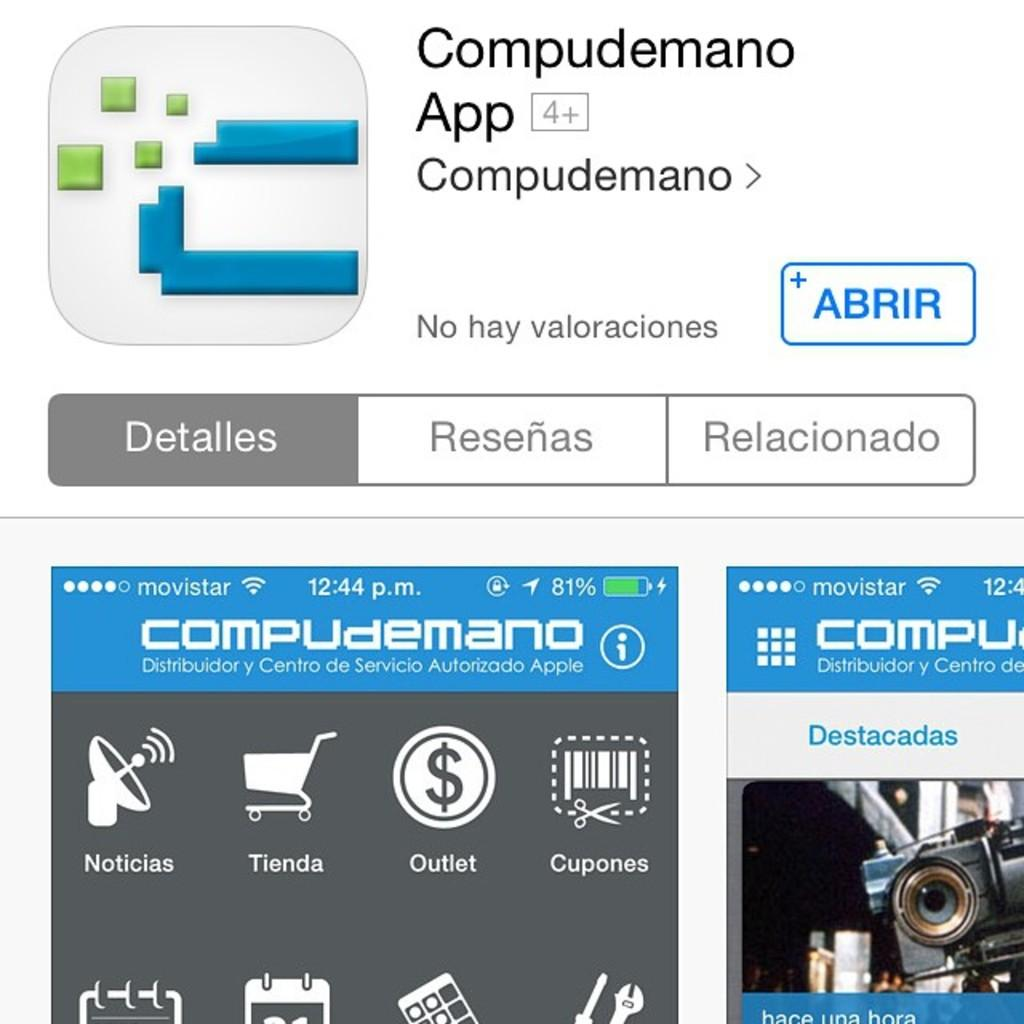What is the main subject of the image? The main subject of the image is a web page. What type of information is displayed on the web page? The web page contains details of an app. Is there any visual representation of the app on the web page? Yes, the web page includes a preview of the app. What type of straw is used to create the fear in the image? There is no straw or fear present in the image; it features a web page with details of an app and a preview. 